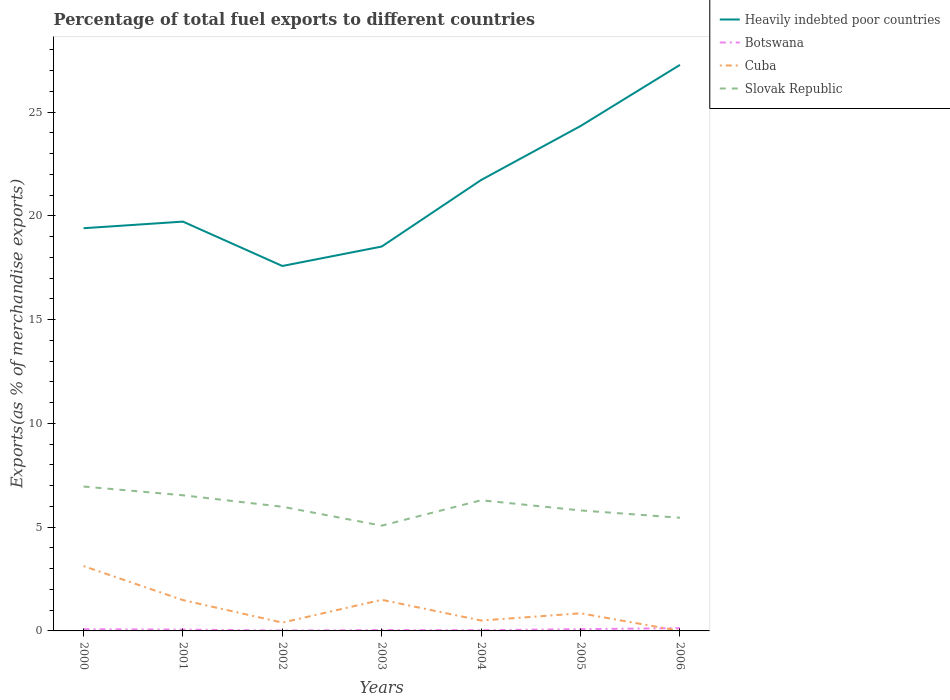Across all years, what is the maximum percentage of exports to different countries in Slovak Republic?
Your answer should be compact. 5.07. In which year was the percentage of exports to different countries in Cuba maximum?
Offer a terse response. 2006. What is the total percentage of exports to different countries in Cuba in the graph?
Give a very brief answer. -0.45. What is the difference between the highest and the second highest percentage of exports to different countries in Botswana?
Your answer should be very brief. 0.12. What is the difference between the highest and the lowest percentage of exports to different countries in Cuba?
Make the answer very short. 3. Is the percentage of exports to different countries in Slovak Republic strictly greater than the percentage of exports to different countries in Cuba over the years?
Ensure brevity in your answer.  No. How many years are there in the graph?
Keep it short and to the point. 7. What is the difference between two consecutive major ticks on the Y-axis?
Ensure brevity in your answer.  5. Does the graph contain grids?
Provide a succinct answer. No. How are the legend labels stacked?
Offer a very short reply. Vertical. What is the title of the graph?
Your answer should be compact. Percentage of total fuel exports to different countries. Does "Vietnam" appear as one of the legend labels in the graph?
Provide a short and direct response. No. What is the label or title of the X-axis?
Your response must be concise. Years. What is the label or title of the Y-axis?
Your answer should be very brief. Exports(as % of merchandise exports). What is the Exports(as % of merchandise exports) of Heavily indebted poor countries in 2000?
Make the answer very short. 19.41. What is the Exports(as % of merchandise exports) in Botswana in 2000?
Ensure brevity in your answer.  0.08. What is the Exports(as % of merchandise exports) of Cuba in 2000?
Your response must be concise. 3.13. What is the Exports(as % of merchandise exports) in Slovak Republic in 2000?
Your response must be concise. 6.96. What is the Exports(as % of merchandise exports) in Heavily indebted poor countries in 2001?
Offer a terse response. 19.73. What is the Exports(as % of merchandise exports) of Botswana in 2001?
Give a very brief answer. 0.07. What is the Exports(as % of merchandise exports) of Cuba in 2001?
Provide a short and direct response. 1.49. What is the Exports(as % of merchandise exports) of Slovak Republic in 2001?
Keep it short and to the point. 6.54. What is the Exports(as % of merchandise exports) in Heavily indebted poor countries in 2002?
Offer a terse response. 17.59. What is the Exports(as % of merchandise exports) of Botswana in 2002?
Provide a short and direct response. 0.02. What is the Exports(as % of merchandise exports) of Cuba in 2002?
Provide a succinct answer. 0.4. What is the Exports(as % of merchandise exports) of Slovak Republic in 2002?
Keep it short and to the point. 5.98. What is the Exports(as % of merchandise exports) of Heavily indebted poor countries in 2003?
Give a very brief answer. 18.52. What is the Exports(as % of merchandise exports) of Botswana in 2003?
Your response must be concise. 0.04. What is the Exports(as % of merchandise exports) in Cuba in 2003?
Your answer should be compact. 1.5. What is the Exports(as % of merchandise exports) in Slovak Republic in 2003?
Give a very brief answer. 5.07. What is the Exports(as % of merchandise exports) in Heavily indebted poor countries in 2004?
Provide a short and direct response. 21.73. What is the Exports(as % of merchandise exports) of Botswana in 2004?
Provide a succinct answer. 0.04. What is the Exports(as % of merchandise exports) in Cuba in 2004?
Offer a terse response. 0.5. What is the Exports(as % of merchandise exports) in Slovak Republic in 2004?
Provide a succinct answer. 6.3. What is the Exports(as % of merchandise exports) in Heavily indebted poor countries in 2005?
Provide a succinct answer. 24.33. What is the Exports(as % of merchandise exports) in Botswana in 2005?
Ensure brevity in your answer.  0.09. What is the Exports(as % of merchandise exports) of Cuba in 2005?
Keep it short and to the point. 0.85. What is the Exports(as % of merchandise exports) in Slovak Republic in 2005?
Provide a short and direct response. 5.81. What is the Exports(as % of merchandise exports) in Heavily indebted poor countries in 2006?
Your answer should be very brief. 27.28. What is the Exports(as % of merchandise exports) in Botswana in 2006?
Provide a short and direct response. 0.13. What is the Exports(as % of merchandise exports) in Cuba in 2006?
Offer a terse response. 0. What is the Exports(as % of merchandise exports) in Slovak Republic in 2006?
Give a very brief answer. 5.45. Across all years, what is the maximum Exports(as % of merchandise exports) in Heavily indebted poor countries?
Keep it short and to the point. 27.28. Across all years, what is the maximum Exports(as % of merchandise exports) of Botswana?
Your answer should be compact. 0.13. Across all years, what is the maximum Exports(as % of merchandise exports) of Cuba?
Keep it short and to the point. 3.13. Across all years, what is the maximum Exports(as % of merchandise exports) of Slovak Republic?
Give a very brief answer. 6.96. Across all years, what is the minimum Exports(as % of merchandise exports) in Heavily indebted poor countries?
Keep it short and to the point. 17.59. Across all years, what is the minimum Exports(as % of merchandise exports) in Botswana?
Give a very brief answer. 0.02. Across all years, what is the minimum Exports(as % of merchandise exports) of Cuba?
Your answer should be very brief. 0. Across all years, what is the minimum Exports(as % of merchandise exports) in Slovak Republic?
Offer a terse response. 5.07. What is the total Exports(as % of merchandise exports) in Heavily indebted poor countries in the graph?
Your answer should be very brief. 148.59. What is the total Exports(as % of merchandise exports) in Botswana in the graph?
Make the answer very short. 0.46. What is the total Exports(as % of merchandise exports) of Cuba in the graph?
Your answer should be compact. 7.86. What is the total Exports(as % of merchandise exports) in Slovak Republic in the graph?
Offer a very short reply. 42.11. What is the difference between the Exports(as % of merchandise exports) in Heavily indebted poor countries in 2000 and that in 2001?
Your answer should be very brief. -0.32. What is the difference between the Exports(as % of merchandise exports) in Botswana in 2000 and that in 2001?
Ensure brevity in your answer.  0.02. What is the difference between the Exports(as % of merchandise exports) in Cuba in 2000 and that in 2001?
Your answer should be compact. 1.64. What is the difference between the Exports(as % of merchandise exports) of Slovak Republic in 2000 and that in 2001?
Offer a terse response. 0.42. What is the difference between the Exports(as % of merchandise exports) of Heavily indebted poor countries in 2000 and that in 2002?
Provide a succinct answer. 1.82. What is the difference between the Exports(as % of merchandise exports) in Botswana in 2000 and that in 2002?
Make the answer very short. 0.06. What is the difference between the Exports(as % of merchandise exports) in Cuba in 2000 and that in 2002?
Offer a terse response. 2.72. What is the difference between the Exports(as % of merchandise exports) of Slovak Republic in 2000 and that in 2002?
Offer a terse response. 0.97. What is the difference between the Exports(as % of merchandise exports) in Heavily indebted poor countries in 2000 and that in 2003?
Your answer should be compact. 0.88. What is the difference between the Exports(as % of merchandise exports) in Botswana in 2000 and that in 2003?
Ensure brevity in your answer.  0.04. What is the difference between the Exports(as % of merchandise exports) of Cuba in 2000 and that in 2003?
Give a very brief answer. 1.63. What is the difference between the Exports(as % of merchandise exports) of Slovak Republic in 2000 and that in 2003?
Keep it short and to the point. 1.88. What is the difference between the Exports(as % of merchandise exports) in Heavily indebted poor countries in 2000 and that in 2004?
Keep it short and to the point. -2.32. What is the difference between the Exports(as % of merchandise exports) in Botswana in 2000 and that in 2004?
Keep it short and to the point. 0.05. What is the difference between the Exports(as % of merchandise exports) in Cuba in 2000 and that in 2004?
Make the answer very short. 2.63. What is the difference between the Exports(as % of merchandise exports) of Slovak Republic in 2000 and that in 2004?
Your answer should be compact. 0.66. What is the difference between the Exports(as % of merchandise exports) in Heavily indebted poor countries in 2000 and that in 2005?
Make the answer very short. -4.93. What is the difference between the Exports(as % of merchandise exports) in Botswana in 2000 and that in 2005?
Offer a terse response. -0. What is the difference between the Exports(as % of merchandise exports) in Cuba in 2000 and that in 2005?
Offer a very short reply. 2.28. What is the difference between the Exports(as % of merchandise exports) of Slovak Republic in 2000 and that in 2005?
Offer a very short reply. 1.15. What is the difference between the Exports(as % of merchandise exports) of Heavily indebted poor countries in 2000 and that in 2006?
Ensure brevity in your answer.  -7.87. What is the difference between the Exports(as % of merchandise exports) in Botswana in 2000 and that in 2006?
Ensure brevity in your answer.  -0.05. What is the difference between the Exports(as % of merchandise exports) of Cuba in 2000 and that in 2006?
Make the answer very short. 3.12. What is the difference between the Exports(as % of merchandise exports) of Slovak Republic in 2000 and that in 2006?
Offer a very short reply. 1.5. What is the difference between the Exports(as % of merchandise exports) of Heavily indebted poor countries in 2001 and that in 2002?
Ensure brevity in your answer.  2.14. What is the difference between the Exports(as % of merchandise exports) in Botswana in 2001 and that in 2002?
Provide a succinct answer. 0.05. What is the difference between the Exports(as % of merchandise exports) of Cuba in 2001 and that in 2002?
Give a very brief answer. 1.08. What is the difference between the Exports(as % of merchandise exports) of Slovak Republic in 2001 and that in 2002?
Your answer should be very brief. 0.55. What is the difference between the Exports(as % of merchandise exports) of Heavily indebted poor countries in 2001 and that in 2003?
Ensure brevity in your answer.  1.2. What is the difference between the Exports(as % of merchandise exports) of Botswana in 2001 and that in 2003?
Your response must be concise. 0.02. What is the difference between the Exports(as % of merchandise exports) in Cuba in 2001 and that in 2003?
Make the answer very short. -0.01. What is the difference between the Exports(as % of merchandise exports) of Slovak Republic in 2001 and that in 2003?
Keep it short and to the point. 1.46. What is the difference between the Exports(as % of merchandise exports) of Heavily indebted poor countries in 2001 and that in 2004?
Offer a very short reply. -2.01. What is the difference between the Exports(as % of merchandise exports) in Botswana in 2001 and that in 2004?
Provide a succinct answer. 0.03. What is the difference between the Exports(as % of merchandise exports) in Cuba in 2001 and that in 2004?
Offer a very short reply. 0.99. What is the difference between the Exports(as % of merchandise exports) in Slovak Republic in 2001 and that in 2004?
Provide a succinct answer. 0.24. What is the difference between the Exports(as % of merchandise exports) in Heavily indebted poor countries in 2001 and that in 2005?
Give a very brief answer. -4.61. What is the difference between the Exports(as % of merchandise exports) in Botswana in 2001 and that in 2005?
Offer a very short reply. -0.02. What is the difference between the Exports(as % of merchandise exports) of Cuba in 2001 and that in 2005?
Your response must be concise. 0.64. What is the difference between the Exports(as % of merchandise exports) of Slovak Republic in 2001 and that in 2005?
Your answer should be very brief. 0.73. What is the difference between the Exports(as % of merchandise exports) of Heavily indebted poor countries in 2001 and that in 2006?
Your response must be concise. -7.55. What is the difference between the Exports(as % of merchandise exports) of Botswana in 2001 and that in 2006?
Give a very brief answer. -0.07. What is the difference between the Exports(as % of merchandise exports) of Cuba in 2001 and that in 2006?
Your answer should be compact. 1.48. What is the difference between the Exports(as % of merchandise exports) in Slovak Republic in 2001 and that in 2006?
Offer a terse response. 1.08. What is the difference between the Exports(as % of merchandise exports) in Heavily indebted poor countries in 2002 and that in 2003?
Your answer should be very brief. -0.94. What is the difference between the Exports(as % of merchandise exports) of Botswana in 2002 and that in 2003?
Keep it short and to the point. -0.02. What is the difference between the Exports(as % of merchandise exports) of Cuba in 2002 and that in 2003?
Your response must be concise. -1.1. What is the difference between the Exports(as % of merchandise exports) in Slovak Republic in 2002 and that in 2003?
Keep it short and to the point. 0.91. What is the difference between the Exports(as % of merchandise exports) in Heavily indebted poor countries in 2002 and that in 2004?
Offer a very short reply. -4.14. What is the difference between the Exports(as % of merchandise exports) in Botswana in 2002 and that in 2004?
Provide a succinct answer. -0.02. What is the difference between the Exports(as % of merchandise exports) in Cuba in 2002 and that in 2004?
Your answer should be very brief. -0.1. What is the difference between the Exports(as % of merchandise exports) in Slovak Republic in 2002 and that in 2004?
Offer a very short reply. -0.31. What is the difference between the Exports(as % of merchandise exports) in Heavily indebted poor countries in 2002 and that in 2005?
Your response must be concise. -6.74. What is the difference between the Exports(as % of merchandise exports) of Botswana in 2002 and that in 2005?
Provide a succinct answer. -0.07. What is the difference between the Exports(as % of merchandise exports) in Cuba in 2002 and that in 2005?
Ensure brevity in your answer.  -0.45. What is the difference between the Exports(as % of merchandise exports) in Slovak Republic in 2002 and that in 2005?
Your answer should be compact. 0.18. What is the difference between the Exports(as % of merchandise exports) in Heavily indebted poor countries in 2002 and that in 2006?
Your answer should be very brief. -9.69. What is the difference between the Exports(as % of merchandise exports) of Botswana in 2002 and that in 2006?
Give a very brief answer. -0.12. What is the difference between the Exports(as % of merchandise exports) in Cuba in 2002 and that in 2006?
Ensure brevity in your answer.  0.4. What is the difference between the Exports(as % of merchandise exports) of Slovak Republic in 2002 and that in 2006?
Your response must be concise. 0.53. What is the difference between the Exports(as % of merchandise exports) of Heavily indebted poor countries in 2003 and that in 2004?
Provide a succinct answer. -3.21. What is the difference between the Exports(as % of merchandise exports) of Botswana in 2003 and that in 2004?
Provide a short and direct response. 0.01. What is the difference between the Exports(as % of merchandise exports) of Slovak Republic in 2003 and that in 2004?
Make the answer very short. -1.22. What is the difference between the Exports(as % of merchandise exports) in Heavily indebted poor countries in 2003 and that in 2005?
Keep it short and to the point. -5.81. What is the difference between the Exports(as % of merchandise exports) in Botswana in 2003 and that in 2005?
Offer a very short reply. -0.04. What is the difference between the Exports(as % of merchandise exports) in Cuba in 2003 and that in 2005?
Keep it short and to the point. 0.65. What is the difference between the Exports(as % of merchandise exports) of Slovak Republic in 2003 and that in 2005?
Keep it short and to the point. -0.73. What is the difference between the Exports(as % of merchandise exports) of Heavily indebted poor countries in 2003 and that in 2006?
Provide a short and direct response. -8.75. What is the difference between the Exports(as % of merchandise exports) of Botswana in 2003 and that in 2006?
Your answer should be compact. -0.09. What is the difference between the Exports(as % of merchandise exports) of Cuba in 2003 and that in 2006?
Offer a very short reply. 1.5. What is the difference between the Exports(as % of merchandise exports) in Slovak Republic in 2003 and that in 2006?
Your answer should be compact. -0.38. What is the difference between the Exports(as % of merchandise exports) in Heavily indebted poor countries in 2004 and that in 2005?
Make the answer very short. -2.6. What is the difference between the Exports(as % of merchandise exports) in Botswana in 2004 and that in 2005?
Your answer should be compact. -0.05. What is the difference between the Exports(as % of merchandise exports) in Cuba in 2004 and that in 2005?
Your answer should be very brief. -0.35. What is the difference between the Exports(as % of merchandise exports) of Slovak Republic in 2004 and that in 2005?
Give a very brief answer. 0.49. What is the difference between the Exports(as % of merchandise exports) of Heavily indebted poor countries in 2004 and that in 2006?
Provide a short and direct response. -5.55. What is the difference between the Exports(as % of merchandise exports) in Botswana in 2004 and that in 2006?
Provide a short and direct response. -0.1. What is the difference between the Exports(as % of merchandise exports) of Cuba in 2004 and that in 2006?
Ensure brevity in your answer.  0.5. What is the difference between the Exports(as % of merchandise exports) in Slovak Republic in 2004 and that in 2006?
Your answer should be compact. 0.84. What is the difference between the Exports(as % of merchandise exports) of Heavily indebted poor countries in 2005 and that in 2006?
Your answer should be very brief. -2.95. What is the difference between the Exports(as % of merchandise exports) of Botswana in 2005 and that in 2006?
Make the answer very short. -0.05. What is the difference between the Exports(as % of merchandise exports) in Cuba in 2005 and that in 2006?
Your answer should be compact. 0.85. What is the difference between the Exports(as % of merchandise exports) of Slovak Republic in 2005 and that in 2006?
Make the answer very short. 0.35. What is the difference between the Exports(as % of merchandise exports) of Heavily indebted poor countries in 2000 and the Exports(as % of merchandise exports) of Botswana in 2001?
Offer a terse response. 19.34. What is the difference between the Exports(as % of merchandise exports) of Heavily indebted poor countries in 2000 and the Exports(as % of merchandise exports) of Cuba in 2001?
Offer a very short reply. 17.92. What is the difference between the Exports(as % of merchandise exports) in Heavily indebted poor countries in 2000 and the Exports(as % of merchandise exports) in Slovak Republic in 2001?
Offer a very short reply. 12.87. What is the difference between the Exports(as % of merchandise exports) of Botswana in 2000 and the Exports(as % of merchandise exports) of Cuba in 2001?
Ensure brevity in your answer.  -1.4. What is the difference between the Exports(as % of merchandise exports) in Botswana in 2000 and the Exports(as % of merchandise exports) in Slovak Republic in 2001?
Give a very brief answer. -6.46. What is the difference between the Exports(as % of merchandise exports) of Cuba in 2000 and the Exports(as % of merchandise exports) of Slovak Republic in 2001?
Provide a succinct answer. -3.41. What is the difference between the Exports(as % of merchandise exports) in Heavily indebted poor countries in 2000 and the Exports(as % of merchandise exports) in Botswana in 2002?
Offer a very short reply. 19.39. What is the difference between the Exports(as % of merchandise exports) in Heavily indebted poor countries in 2000 and the Exports(as % of merchandise exports) in Cuba in 2002?
Provide a succinct answer. 19.01. What is the difference between the Exports(as % of merchandise exports) of Heavily indebted poor countries in 2000 and the Exports(as % of merchandise exports) of Slovak Republic in 2002?
Give a very brief answer. 13.42. What is the difference between the Exports(as % of merchandise exports) in Botswana in 2000 and the Exports(as % of merchandise exports) in Cuba in 2002?
Offer a terse response. -0.32. What is the difference between the Exports(as % of merchandise exports) in Botswana in 2000 and the Exports(as % of merchandise exports) in Slovak Republic in 2002?
Your answer should be compact. -5.9. What is the difference between the Exports(as % of merchandise exports) of Cuba in 2000 and the Exports(as % of merchandise exports) of Slovak Republic in 2002?
Make the answer very short. -2.86. What is the difference between the Exports(as % of merchandise exports) in Heavily indebted poor countries in 2000 and the Exports(as % of merchandise exports) in Botswana in 2003?
Offer a very short reply. 19.37. What is the difference between the Exports(as % of merchandise exports) in Heavily indebted poor countries in 2000 and the Exports(as % of merchandise exports) in Cuba in 2003?
Offer a terse response. 17.91. What is the difference between the Exports(as % of merchandise exports) of Heavily indebted poor countries in 2000 and the Exports(as % of merchandise exports) of Slovak Republic in 2003?
Offer a terse response. 14.33. What is the difference between the Exports(as % of merchandise exports) in Botswana in 2000 and the Exports(as % of merchandise exports) in Cuba in 2003?
Give a very brief answer. -1.42. What is the difference between the Exports(as % of merchandise exports) of Botswana in 2000 and the Exports(as % of merchandise exports) of Slovak Republic in 2003?
Provide a succinct answer. -4.99. What is the difference between the Exports(as % of merchandise exports) in Cuba in 2000 and the Exports(as % of merchandise exports) in Slovak Republic in 2003?
Give a very brief answer. -1.95. What is the difference between the Exports(as % of merchandise exports) of Heavily indebted poor countries in 2000 and the Exports(as % of merchandise exports) of Botswana in 2004?
Offer a very short reply. 19.37. What is the difference between the Exports(as % of merchandise exports) of Heavily indebted poor countries in 2000 and the Exports(as % of merchandise exports) of Cuba in 2004?
Your response must be concise. 18.91. What is the difference between the Exports(as % of merchandise exports) of Heavily indebted poor countries in 2000 and the Exports(as % of merchandise exports) of Slovak Republic in 2004?
Provide a succinct answer. 13.11. What is the difference between the Exports(as % of merchandise exports) in Botswana in 2000 and the Exports(as % of merchandise exports) in Cuba in 2004?
Your answer should be very brief. -0.42. What is the difference between the Exports(as % of merchandise exports) of Botswana in 2000 and the Exports(as % of merchandise exports) of Slovak Republic in 2004?
Your answer should be very brief. -6.22. What is the difference between the Exports(as % of merchandise exports) of Cuba in 2000 and the Exports(as % of merchandise exports) of Slovak Republic in 2004?
Offer a terse response. -3.17. What is the difference between the Exports(as % of merchandise exports) of Heavily indebted poor countries in 2000 and the Exports(as % of merchandise exports) of Botswana in 2005?
Offer a terse response. 19.32. What is the difference between the Exports(as % of merchandise exports) in Heavily indebted poor countries in 2000 and the Exports(as % of merchandise exports) in Cuba in 2005?
Offer a terse response. 18.56. What is the difference between the Exports(as % of merchandise exports) in Heavily indebted poor countries in 2000 and the Exports(as % of merchandise exports) in Slovak Republic in 2005?
Offer a very short reply. 13.6. What is the difference between the Exports(as % of merchandise exports) in Botswana in 2000 and the Exports(as % of merchandise exports) in Cuba in 2005?
Provide a succinct answer. -0.77. What is the difference between the Exports(as % of merchandise exports) in Botswana in 2000 and the Exports(as % of merchandise exports) in Slovak Republic in 2005?
Provide a short and direct response. -5.72. What is the difference between the Exports(as % of merchandise exports) in Cuba in 2000 and the Exports(as % of merchandise exports) in Slovak Republic in 2005?
Give a very brief answer. -2.68. What is the difference between the Exports(as % of merchandise exports) in Heavily indebted poor countries in 2000 and the Exports(as % of merchandise exports) in Botswana in 2006?
Keep it short and to the point. 19.27. What is the difference between the Exports(as % of merchandise exports) in Heavily indebted poor countries in 2000 and the Exports(as % of merchandise exports) in Cuba in 2006?
Ensure brevity in your answer.  19.41. What is the difference between the Exports(as % of merchandise exports) in Heavily indebted poor countries in 2000 and the Exports(as % of merchandise exports) in Slovak Republic in 2006?
Your answer should be compact. 13.95. What is the difference between the Exports(as % of merchandise exports) of Botswana in 2000 and the Exports(as % of merchandise exports) of Cuba in 2006?
Keep it short and to the point. 0.08. What is the difference between the Exports(as % of merchandise exports) of Botswana in 2000 and the Exports(as % of merchandise exports) of Slovak Republic in 2006?
Ensure brevity in your answer.  -5.37. What is the difference between the Exports(as % of merchandise exports) of Cuba in 2000 and the Exports(as % of merchandise exports) of Slovak Republic in 2006?
Offer a very short reply. -2.33. What is the difference between the Exports(as % of merchandise exports) in Heavily indebted poor countries in 2001 and the Exports(as % of merchandise exports) in Botswana in 2002?
Offer a terse response. 19.71. What is the difference between the Exports(as % of merchandise exports) of Heavily indebted poor countries in 2001 and the Exports(as % of merchandise exports) of Cuba in 2002?
Your response must be concise. 19.32. What is the difference between the Exports(as % of merchandise exports) in Heavily indebted poor countries in 2001 and the Exports(as % of merchandise exports) in Slovak Republic in 2002?
Provide a succinct answer. 13.74. What is the difference between the Exports(as % of merchandise exports) in Botswana in 2001 and the Exports(as % of merchandise exports) in Cuba in 2002?
Make the answer very short. -0.34. What is the difference between the Exports(as % of merchandise exports) in Botswana in 2001 and the Exports(as % of merchandise exports) in Slovak Republic in 2002?
Make the answer very short. -5.92. What is the difference between the Exports(as % of merchandise exports) in Cuba in 2001 and the Exports(as % of merchandise exports) in Slovak Republic in 2002?
Make the answer very short. -4.5. What is the difference between the Exports(as % of merchandise exports) of Heavily indebted poor countries in 2001 and the Exports(as % of merchandise exports) of Botswana in 2003?
Make the answer very short. 19.68. What is the difference between the Exports(as % of merchandise exports) of Heavily indebted poor countries in 2001 and the Exports(as % of merchandise exports) of Cuba in 2003?
Your answer should be very brief. 18.23. What is the difference between the Exports(as % of merchandise exports) in Heavily indebted poor countries in 2001 and the Exports(as % of merchandise exports) in Slovak Republic in 2003?
Ensure brevity in your answer.  14.65. What is the difference between the Exports(as % of merchandise exports) in Botswana in 2001 and the Exports(as % of merchandise exports) in Cuba in 2003?
Keep it short and to the point. -1.44. What is the difference between the Exports(as % of merchandise exports) in Botswana in 2001 and the Exports(as % of merchandise exports) in Slovak Republic in 2003?
Offer a very short reply. -5.01. What is the difference between the Exports(as % of merchandise exports) of Cuba in 2001 and the Exports(as % of merchandise exports) of Slovak Republic in 2003?
Provide a short and direct response. -3.59. What is the difference between the Exports(as % of merchandise exports) in Heavily indebted poor countries in 2001 and the Exports(as % of merchandise exports) in Botswana in 2004?
Keep it short and to the point. 19.69. What is the difference between the Exports(as % of merchandise exports) of Heavily indebted poor countries in 2001 and the Exports(as % of merchandise exports) of Cuba in 2004?
Provide a short and direct response. 19.23. What is the difference between the Exports(as % of merchandise exports) of Heavily indebted poor countries in 2001 and the Exports(as % of merchandise exports) of Slovak Republic in 2004?
Your answer should be very brief. 13.43. What is the difference between the Exports(as % of merchandise exports) of Botswana in 2001 and the Exports(as % of merchandise exports) of Cuba in 2004?
Provide a short and direct response. -0.44. What is the difference between the Exports(as % of merchandise exports) in Botswana in 2001 and the Exports(as % of merchandise exports) in Slovak Republic in 2004?
Your response must be concise. -6.23. What is the difference between the Exports(as % of merchandise exports) in Cuba in 2001 and the Exports(as % of merchandise exports) in Slovak Republic in 2004?
Give a very brief answer. -4.81. What is the difference between the Exports(as % of merchandise exports) of Heavily indebted poor countries in 2001 and the Exports(as % of merchandise exports) of Botswana in 2005?
Offer a very short reply. 19.64. What is the difference between the Exports(as % of merchandise exports) in Heavily indebted poor countries in 2001 and the Exports(as % of merchandise exports) in Cuba in 2005?
Your answer should be very brief. 18.88. What is the difference between the Exports(as % of merchandise exports) in Heavily indebted poor countries in 2001 and the Exports(as % of merchandise exports) in Slovak Republic in 2005?
Give a very brief answer. 13.92. What is the difference between the Exports(as % of merchandise exports) of Botswana in 2001 and the Exports(as % of merchandise exports) of Cuba in 2005?
Make the answer very short. -0.78. What is the difference between the Exports(as % of merchandise exports) in Botswana in 2001 and the Exports(as % of merchandise exports) in Slovak Republic in 2005?
Provide a succinct answer. -5.74. What is the difference between the Exports(as % of merchandise exports) in Cuba in 2001 and the Exports(as % of merchandise exports) in Slovak Republic in 2005?
Offer a very short reply. -4.32. What is the difference between the Exports(as % of merchandise exports) in Heavily indebted poor countries in 2001 and the Exports(as % of merchandise exports) in Botswana in 2006?
Your answer should be very brief. 19.59. What is the difference between the Exports(as % of merchandise exports) in Heavily indebted poor countries in 2001 and the Exports(as % of merchandise exports) in Cuba in 2006?
Make the answer very short. 19.72. What is the difference between the Exports(as % of merchandise exports) in Heavily indebted poor countries in 2001 and the Exports(as % of merchandise exports) in Slovak Republic in 2006?
Ensure brevity in your answer.  14.27. What is the difference between the Exports(as % of merchandise exports) of Botswana in 2001 and the Exports(as % of merchandise exports) of Cuba in 2006?
Give a very brief answer. 0.06. What is the difference between the Exports(as % of merchandise exports) in Botswana in 2001 and the Exports(as % of merchandise exports) in Slovak Republic in 2006?
Offer a very short reply. -5.39. What is the difference between the Exports(as % of merchandise exports) in Cuba in 2001 and the Exports(as % of merchandise exports) in Slovak Republic in 2006?
Offer a very short reply. -3.97. What is the difference between the Exports(as % of merchandise exports) of Heavily indebted poor countries in 2002 and the Exports(as % of merchandise exports) of Botswana in 2003?
Your response must be concise. 17.55. What is the difference between the Exports(as % of merchandise exports) of Heavily indebted poor countries in 2002 and the Exports(as % of merchandise exports) of Cuba in 2003?
Ensure brevity in your answer.  16.09. What is the difference between the Exports(as % of merchandise exports) in Heavily indebted poor countries in 2002 and the Exports(as % of merchandise exports) in Slovak Republic in 2003?
Provide a short and direct response. 12.51. What is the difference between the Exports(as % of merchandise exports) of Botswana in 2002 and the Exports(as % of merchandise exports) of Cuba in 2003?
Your answer should be compact. -1.48. What is the difference between the Exports(as % of merchandise exports) of Botswana in 2002 and the Exports(as % of merchandise exports) of Slovak Republic in 2003?
Ensure brevity in your answer.  -5.06. What is the difference between the Exports(as % of merchandise exports) of Cuba in 2002 and the Exports(as % of merchandise exports) of Slovak Republic in 2003?
Make the answer very short. -4.67. What is the difference between the Exports(as % of merchandise exports) of Heavily indebted poor countries in 2002 and the Exports(as % of merchandise exports) of Botswana in 2004?
Your response must be concise. 17.55. What is the difference between the Exports(as % of merchandise exports) in Heavily indebted poor countries in 2002 and the Exports(as % of merchandise exports) in Cuba in 2004?
Your answer should be very brief. 17.09. What is the difference between the Exports(as % of merchandise exports) of Heavily indebted poor countries in 2002 and the Exports(as % of merchandise exports) of Slovak Republic in 2004?
Give a very brief answer. 11.29. What is the difference between the Exports(as % of merchandise exports) of Botswana in 2002 and the Exports(as % of merchandise exports) of Cuba in 2004?
Ensure brevity in your answer.  -0.48. What is the difference between the Exports(as % of merchandise exports) in Botswana in 2002 and the Exports(as % of merchandise exports) in Slovak Republic in 2004?
Your response must be concise. -6.28. What is the difference between the Exports(as % of merchandise exports) in Cuba in 2002 and the Exports(as % of merchandise exports) in Slovak Republic in 2004?
Provide a short and direct response. -5.9. What is the difference between the Exports(as % of merchandise exports) in Heavily indebted poor countries in 2002 and the Exports(as % of merchandise exports) in Botswana in 2005?
Your response must be concise. 17.5. What is the difference between the Exports(as % of merchandise exports) of Heavily indebted poor countries in 2002 and the Exports(as % of merchandise exports) of Cuba in 2005?
Provide a short and direct response. 16.74. What is the difference between the Exports(as % of merchandise exports) in Heavily indebted poor countries in 2002 and the Exports(as % of merchandise exports) in Slovak Republic in 2005?
Offer a very short reply. 11.78. What is the difference between the Exports(as % of merchandise exports) in Botswana in 2002 and the Exports(as % of merchandise exports) in Cuba in 2005?
Provide a succinct answer. -0.83. What is the difference between the Exports(as % of merchandise exports) of Botswana in 2002 and the Exports(as % of merchandise exports) of Slovak Republic in 2005?
Ensure brevity in your answer.  -5.79. What is the difference between the Exports(as % of merchandise exports) of Cuba in 2002 and the Exports(as % of merchandise exports) of Slovak Republic in 2005?
Ensure brevity in your answer.  -5.4. What is the difference between the Exports(as % of merchandise exports) of Heavily indebted poor countries in 2002 and the Exports(as % of merchandise exports) of Botswana in 2006?
Offer a terse response. 17.45. What is the difference between the Exports(as % of merchandise exports) in Heavily indebted poor countries in 2002 and the Exports(as % of merchandise exports) in Cuba in 2006?
Offer a terse response. 17.59. What is the difference between the Exports(as % of merchandise exports) of Heavily indebted poor countries in 2002 and the Exports(as % of merchandise exports) of Slovak Republic in 2006?
Keep it short and to the point. 12.13. What is the difference between the Exports(as % of merchandise exports) in Botswana in 2002 and the Exports(as % of merchandise exports) in Cuba in 2006?
Give a very brief answer. 0.02. What is the difference between the Exports(as % of merchandise exports) in Botswana in 2002 and the Exports(as % of merchandise exports) in Slovak Republic in 2006?
Ensure brevity in your answer.  -5.44. What is the difference between the Exports(as % of merchandise exports) in Cuba in 2002 and the Exports(as % of merchandise exports) in Slovak Republic in 2006?
Make the answer very short. -5.05. What is the difference between the Exports(as % of merchandise exports) of Heavily indebted poor countries in 2003 and the Exports(as % of merchandise exports) of Botswana in 2004?
Your answer should be compact. 18.49. What is the difference between the Exports(as % of merchandise exports) in Heavily indebted poor countries in 2003 and the Exports(as % of merchandise exports) in Cuba in 2004?
Offer a very short reply. 18.02. What is the difference between the Exports(as % of merchandise exports) in Heavily indebted poor countries in 2003 and the Exports(as % of merchandise exports) in Slovak Republic in 2004?
Offer a very short reply. 12.23. What is the difference between the Exports(as % of merchandise exports) of Botswana in 2003 and the Exports(as % of merchandise exports) of Cuba in 2004?
Your response must be concise. -0.46. What is the difference between the Exports(as % of merchandise exports) of Botswana in 2003 and the Exports(as % of merchandise exports) of Slovak Republic in 2004?
Offer a terse response. -6.26. What is the difference between the Exports(as % of merchandise exports) of Cuba in 2003 and the Exports(as % of merchandise exports) of Slovak Republic in 2004?
Ensure brevity in your answer.  -4.8. What is the difference between the Exports(as % of merchandise exports) in Heavily indebted poor countries in 2003 and the Exports(as % of merchandise exports) in Botswana in 2005?
Your response must be concise. 18.44. What is the difference between the Exports(as % of merchandise exports) in Heavily indebted poor countries in 2003 and the Exports(as % of merchandise exports) in Cuba in 2005?
Offer a terse response. 17.68. What is the difference between the Exports(as % of merchandise exports) of Heavily indebted poor countries in 2003 and the Exports(as % of merchandise exports) of Slovak Republic in 2005?
Offer a terse response. 12.72. What is the difference between the Exports(as % of merchandise exports) of Botswana in 2003 and the Exports(as % of merchandise exports) of Cuba in 2005?
Offer a very short reply. -0.81. What is the difference between the Exports(as % of merchandise exports) in Botswana in 2003 and the Exports(as % of merchandise exports) in Slovak Republic in 2005?
Give a very brief answer. -5.77. What is the difference between the Exports(as % of merchandise exports) in Cuba in 2003 and the Exports(as % of merchandise exports) in Slovak Republic in 2005?
Offer a very short reply. -4.31. What is the difference between the Exports(as % of merchandise exports) in Heavily indebted poor countries in 2003 and the Exports(as % of merchandise exports) in Botswana in 2006?
Offer a very short reply. 18.39. What is the difference between the Exports(as % of merchandise exports) in Heavily indebted poor countries in 2003 and the Exports(as % of merchandise exports) in Cuba in 2006?
Your answer should be compact. 18.52. What is the difference between the Exports(as % of merchandise exports) of Heavily indebted poor countries in 2003 and the Exports(as % of merchandise exports) of Slovak Republic in 2006?
Make the answer very short. 13.07. What is the difference between the Exports(as % of merchandise exports) of Botswana in 2003 and the Exports(as % of merchandise exports) of Cuba in 2006?
Your answer should be very brief. 0.04. What is the difference between the Exports(as % of merchandise exports) of Botswana in 2003 and the Exports(as % of merchandise exports) of Slovak Republic in 2006?
Offer a terse response. -5.41. What is the difference between the Exports(as % of merchandise exports) of Cuba in 2003 and the Exports(as % of merchandise exports) of Slovak Republic in 2006?
Your answer should be very brief. -3.95. What is the difference between the Exports(as % of merchandise exports) of Heavily indebted poor countries in 2004 and the Exports(as % of merchandise exports) of Botswana in 2005?
Give a very brief answer. 21.65. What is the difference between the Exports(as % of merchandise exports) in Heavily indebted poor countries in 2004 and the Exports(as % of merchandise exports) in Cuba in 2005?
Ensure brevity in your answer.  20.88. What is the difference between the Exports(as % of merchandise exports) of Heavily indebted poor countries in 2004 and the Exports(as % of merchandise exports) of Slovak Republic in 2005?
Keep it short and to the point. 15.92. What is the difference between the Exports(as % of merchandise exports) in Botswana in 2004 and the Exports(as % of merchandise exports) in Cuba in 2005?
Provide a succinct answer. -0.81. What is the difference between the Exports(as % of merchandise exports) in Botswana in 2004 and the Exports(as % of merchandise exports) in Slovak Republic in 2005?
Give a very brief answer. -5.77. What is the difference between the Exports(as % of merchandise exports) of Cuba in 2004 and the Exports(as % of merchandise exports) of Slovak Republic in 2005?
Make the answer very short. -5.31. What is the difference between the Exports(as % of merchandise exports) in Heavily indebted poor countries in 2004 and the Exports(as % of merchandise exports) in Botswana in 2006?
Make the answer very short. 21.6. What is the difference between the Exports(as % of merchandise exports) in Heavily indebted poor countries in 2004 and the Exports(as % of merchandise exports) in Cuba in 2006?
Provide a short and direct response. 21.73. What is the difference between the Exports(as % of merchandise exports) in Heavily indebted poor countries in 2004 and the Exports(as % of merchandise exports) in Slovak Republic in 2006?
Offer a very short reply. 16.28. What is the difference between the Exports(as % of merchandise exports) in Botswana in 2004 and the Exports(as % of merchandise exports) in Cuba in 2006?
Provide a succinct answer. 0.03. What is the difference between the Exports(as % of merchandise exports) in Botswana in 2004 and the Exports(as % of merchandise exports) in Slovak Republic in 2006?
Your answer should be very brief. -5.42. What is the difference between the Exports(as % of merchandise exports) in Cuba in 2004 and the Exports(as % of merchandise exports) in Slovak Republic in 2006?
Offer a terse response. -4.95. What is the difference between the Exports(as % of merchandise exports) in Heavily indebted poor countries in 2005 and the Exports(as % of merchandise exports) in Botswana in 2006?
Your answer should be very brief. 24.2. What is the difference between the Exports(as % of merchandise exports) of Heavily indebted poor countries in 2005 and the Exports(as % of merchandise exports) of Cuba in 2006?
Your response must be concise. 24.33. What is the difference between the Exports(as % of merchandise exports) in Heavily indebted poor countries in 2005 and the Exports(as % of merchandise exports) in Slovak Republic in 2006?
Provide a succinct answer. 18.88. What is the difference between the Exports(as % of merchandise exports) in Botswana in 2005 and the Exports(as % of merchandise exports) in Cuba in 2006?
Provide a short and direct response. 0.08. What is the difference between the Exports(as % of merchandise exports) of Botswana in 2005 and the Exports(as % of merchandise exports) of Slovak Republic in 2006?
Give a very brief answer. -5.37. What is the difference between the Exports(as % of merchandise exports) in Cuba in 2005 and the Exports(as % of merchandise exports) in Slovak Republic in 2006?
Provide a short and direct response. -4.6. What is the average Exports(as % of merchandise exports) in Heavily indebted poor countries per year?
Keep it short and to the point. 21.23. What is the average Exports(as % of merchandise exports) in Botswana per year?
Your answer should be very brief. 0.07. What is the average Exports(as % of merchandise exports) in Cuba per year?
Offer a very short reply. 1.12. What is the average Exports(as % of merchandise exports) of Slovak Republic per year?
Offer a terse response. 6.02. In the year 2000, what is the difference between the Exports(as % of merchandise exports) of Heavily indebted poor countries and Exports(as % of merchandise exports) of Botswana?
Offer a very short reply. 19.32. In the year 2000, what is the difference between the Exports(as % of merchandise exports) in Heavily indebted poor countries and Exports(as % of merchandise exports) in Cuba?
Provide a succinct answer. 16.28. In the year 2000, what is the difference between the Exports(as % of merchandise exports) in Heavily indebted poor countries and Exports(as % of merchandise exports) in Slovak Republic?
Offer a very short reply. 12.45. In the year 2000, what is the difference between the Exports(as % of merchandise exports) in Botswana and Exports(as % of merchandise exports) in Cuba?
Offer a very short reply. -3.04. In the year 2000, what is the difference between the Exports(as % of merchandise exports) in Botswana and Exports(as % of merchandise exports) in Slovak Republic?
Offer a terse response. -6.88. In the year 2000, what is the difference between the Exports(as % of merchandise exports) of Cuba and Exports(as % of merchandise exports) of Slovak Republic?
Make the answer very short. -3.83. In the year 2001, what is the difference between the Exports(as % of merchandise exports) in Heavily indebted poor countries and Exports(as % of merchandise exports) in Botswana?
Your answer should be compact. 19.66. In the year 2001, what is the difference between the Exports(as % of merchandise exports) of Heavily indebted poor countries and Exports(as % of merchandise exports) of Cuba?
Make the answer very short. 18.24. In the year 2001, what is the difference between the Exports(as % of merchandise exports) of Heavily indebted poor countries and Exports(as % of merchandise exports) of Slovak Republic?
Keep it short and to the point. 13.19. In the year 2001, what is the difference between the Exports(as % of merchandise exports) in Botswana and Exports(as % of merchandise exports) in Cuba?
Provide a short and direct response. -1.42. In the year 2001, what is the difference between the Exports(as % of merchandise exports) in Botswana and Exports(as % of merchandise exports) in Slovak Republic?
Ensure brevity in your answer.  -6.47. In the year 2001, what is the difference between the Exports(as % of merchandise exports) of Cuba and Exports(as % of merchandise exports) of Slovak Republic?
Your answer should be compact. -5.05. In the year 2002, what is the difference between the Exports(as % of merchandise exports) in Heavily indebted poor countries and Exports(as % of merchandise exports) in Botswana?
Provide a succinct answer. 17.57. In the year 2002, what is the difference between the Exports(as % of merchandise exports) in Heavily indebted poor countries and Exports(as % of merchandise exports) in Cuba?
Your answer should be very brief. 17.19. In the year 2002, what is the difference between the Exports(as % of merchandise exports) in Heavily indebted poor countries and Exports(as % of merchandise exports) in Slovak Republic?
Your answer should be very brief. 11.6. In the year 2002, what is the difference between the Exports(as % of merchandise exports) in Botswana and Exports(as % of merchandise exports) in Cuba?
Provide a succinct answer. -0.38. In the year 2002, what is the difference between the Exports(as % of merchandise exports) of Botswana and Exports(as % of merchandise exports) of Slovak Republic?
Offer a terse response. -5.97. In the year 2002, what is the difference between the Exports(as % of merchandise exports) in Cuba and Exports(as % of merchandise exports) in Slovak Republic?
Provide a short and direct response. -5.58. In the year 2003, what is the difference between the Exports(as % of merchandise exports) of Heavily indebted poor countries and Exports(as % of merchandise exports) of Botswana?
Make the answer very short. 18.48. In the year 2003, what is the difference between the Exports(as % of merchandise exports) of Heavily indebted poor countries and Exports(as % of merchandise exports) of Cuba?
Offer a terse response. 17.02. In the year 2003, what is the difference between the Exports(as % of merchandise exports) of Heavily indebted poor countries and Exports(as % of merchandise exports) of Slovak Republic?
Your response must be concise. 13.45. In the year 2003, what is the difference between the Exports(as % of merchandise exports) of Botswana and Exports(as % of merchandise exports) of Cuba?
Your answer should be compact. -1.46. In the year 2003, what is the difference between the Exports(as % of merchandise exports) in Botswana and Exports(as % of merchandise exports) in Slovak Republic?
Give a very brief answer. -5.03. In the year 2003, what is the difference between the Exports(as % of merchandise exports) of Cuba and Exports(as % of merchandise exports) of Slovak Republic?
Offer a terse response. -3.57. In the year 2004, what is the difference between the Exports(as % of merchandise exports) of Heavily indebted poor countries and Exports(as % of merchandise exports) of Botswana?
Give a very brief answer. 21.7. In the year 2004, what is the difference between the Exports(as % of merchandise exports) in Heavily indebted poor countries and Exports(as % of merchandise exports) in Cuba?
Offer a terse response. 21.23. In the year 2004, what is the difference between the Exports(as % of merchandise exports) in Heavily indebted poor countries and Exports(as % of merchandise exports) in Slovak Republic?
Provide a short and direct response. 15.43. In the year 2004, what is the difference between the Exports(as % of merchandise exports) in Botswana and Exports(as % of merchandise exports) in Cuba?
Give a very brief answer. -0.47. In the year 2004, what is the difference between the Exports(as % of merchandise exports) of Botswana and Exports(as % of merchandise exports) of Slovak Republic?
Your answer should be compact. -6.26. In the year 2004, what is the difference between the Exports(as % of merchandise exports) in Cuba and Exports(as % of merchandise exports) in Slovak Republic?
Keep it short and to the point. -5.8. In the year 2005, what is the difference between the Exports(as % of merchandise exports) of Heavily indebted poor countries and Exports(as % of merchandise exports) of Botswana?
Ensure brevity in your answer.  24.25. In the year 2005, what is the difference between the Exports(as % of merchandise exports) in Heavily indebted poor countries and Exports(as % of merchandise exports) in Cuba?
Your answer should be compact. 23.48. In the year 2005, what is the difference between the Exports(as % of merchandise exports) in Heavily indebted poor countries and Exports(as % of merchandise exports) in Slovak Republic?
Offer a very short reply. 18.53. In the year 2005, what is the difference between the Exports(as % of merchandise exports) of Botswana and Exports(as % of merchandise exports) of Cuba?
Offer a terse response. -0.76. In the year 2005, what is the difference between the Exports(as % of merchandise exports) in Botswana and Exports(as % of merchandise exports) in Slovak Republic?
Your answer should be compact. -5.72. In the year 2005, what is the difference between the Exports(as % of merchandise exports) in Cuba and Exports(as % of merchandise exports) in Slovak Republic?
Ensure brevity in your answer.  -4.96. In the year 2006, what is the difference between the Exports(as % of merchandise exports) of Heavily indebted poor countries and Exports(as % of merchandise exports) of Botswana?
Your response must be concise. 27.15. In the year 2006, what is the difference between the Exports(as % of merchandise exports) in Heavily indebted poor countries and Exports(as % of merchandise exports) in Cuba?
Give a very brief answer. 27.28. In the year 2006, what is the difference between the Exports(as % of merchandise exports) in Heavily indebted poor countries and Exports(as % of merchandise exports) in Slovak Republic?
Your response must be concise. 21.83. In the year 2006, what is the difference between the Exports(as % of merchandise exports) of Botswana and Exports(as % of merchandise exports) of Cuba?
Provide a succinct answer. 0.13. In the year 2006, what is the difference between the Exports(as % of merchandise exports) of Botswana and Exports(as % of merchandise exports) of Slovak Republic?
Your answer should be very brief. -5.32. In the year 2006, what is the difference between the Exports(as % of merchandise exports) of Cuba and Exports(as % of merchandise exports) of Slovak Republic?
Provide a short and direct response. -5.45. What is the ratio of the Exports(as % of merchandise exports) of Heavily indebted poor countries in 2000 to that in 2001?
Your response must be concise. 0.98. What is the ratio of the Exports(as % of merchandise exports) of Botswana in 2000 to that in 2001?
Provide a succinct answer. 1.25. What is the ratio of the Exports(as % of merchandise exports) in Cuba in 2000 to that in 2001?
Offer a terse response. 2.1. What is the ratio of the Exports(as % of merchandise exports) of Slovak Republic in 2000 to that in 2001?
Your response must be concise. 1.06. What is the ratio of the Exports(as % of merchandise exports) in Heavily indebted poor countries in 2000 to that in 2002?
Give a very brief answer. 1.1. What is the ratio of the Exports(as % of merchandise exports) in Botswana in 2000 to that in 2002?
Your response must be concise. 4.69. What is the ratio of the Exports(as % of merchandise exports) in Cuba in 2000 to that in 2002?
Keep it short and to the point. 7.78. What is the ratio of the Exports(as % of merchandise exports) in Slovak Republic in 2000 to that in 2002?
Your response must be concise. 1.16. What is the ratio of the Exports(as % of merchandise exports) in Heavily indebted poor countries in 2000 to that in 2003?
Provide a short and direct response. 1.05. What is the ratio of the Exports(as % of merchandise exports) of Botswana in 2000 to that in 2003?
Provide a short and direct response. 1.99. What is the ratio of the Exports(as % of merchandise exports) of Cuba in 2000 to that in 2003?
Provide a succinct answer. 2.08. What is the ratio of the Exports(as % of merchandise exports) in Slovak Republic in 2000 to that in 2003?
Offer a terse response. 1.37. What is the ratio of the Exports(as % of merchandise exports) in Heavily indebted poor countries in 2000 to that in 2004?
Offer a very short reply. 0.89. What is the ratio of the Exports(as % of merchandise exports) in Botswana in 2000 to that in 2004?
Your answer should be compact. 2.32. What is the ratio of the Exports(as % of merchandise exports) of Cuba in 2000 to that in 2004?
Provide a succinct answer. 6.25. What is the ratio of the Exports(as % of merchandise exports) of Slovak Republic in 2000 to that in 2004?
Keep it short and to the point. 1.1. What is the ratio of the Exports(as % of merchandise exports) of Heavily indebted poor countries in 2000 to that in 2005?
Provide a succinct answer. 0.8. What is the ratio of the Exports(as % of merchandise exports) of Botswana in 2000 to that in 2005?
Ensure brevity in your answer.  0.96. What is the ratio of the Exports(as % of merchandise exports) of Cuba in 2000 to that in 2005?
Give a very brief answer. 3.68. What is the ratio of the Exports(as % of merchandise exports) in Slovak Republic in 2000 to that in 2005?
Offer a terse response. 1.2. What is the ratio of the Exports(as % of merchandise exports) in Heavily indebted poor countries in 2000 to that in 2006?
Give a very brief answer. 0.71. What is the ratio of the Exports(as % of merchandise exports) in Botswana in 2000 to that in 2006?
Give a very brief answer. 0.61. What is the ratio of the Exports(as % of merchandise exports) of Cuba in 2000 to that in 2006?
Offer a terse response. 2046.61. What is the ratio of the Exports(as % of merchandise exports) in Slovak Republic in 2000 to that in 2006?
Keep it short and to the point. 1.28. What is the ratio of the Exports(as % of merchandise exports) of Heavily indebted poor countries in 2001 to that in 2002?
Keep it short and to the point. 1.12. What is the ratio of the Exports(as % of merchandise exports) in Botswana in 2001 to that in 2002?
Offer a very short reply. 3.74. What is the ratio of the Exports(as % of merchandise exports) of Cuba in 2001 to that in 2002?
Your answer should be very brief. 3.7. What is the ratio of the Exports(as % of merchandise exports) in Slovak Republic in 2001 to that in 2002?
Your answer should be compact. 1.09. What is the ratio of the Exports(as % of merchandise exports) in Heavily indebted poor countries in 2001 to that in 2003?
Your answer should be very brief. 1.06. What is the ratio of the Exports(as % of merchandise exports) in Botswana in 2001 to that in 2003?
Your response must be concise. 1.58. What is the ratio of the Exports(as % of merchandise exports) of Cuba in 2001 to that in 2003?
Provide a succinct answer. 0.99. What is the ratio of the Exports(as % of merchandise exports) of Slovak Republic in 2001 to that in 2003?
Your answer should be very brief. 1.29. What is the ratio of the Exports(as % of merchandise exports) of Heavily indebted poor countries in 2001 to that in 2004?
Give a very brief answer. 0.91. What is the ratio of the Exports(as % of merchandise exports) in Botswana in 2001 to that in 2004?
Provide a short and direct response. 1.85. What is the ratio of the Exports(as % of merchandise exports) of Cuba in 2001 to that in 2004?
Keep it short and to the point. 2.97. What is the ratio of the Exports(as % of merchandise exports) in Slovak Republic in 2001 to that in 2004?
Your answer should be very brief. 1.04. What is the ratio of the Exports(as % of merchandise exports) of Heavily indebted poor countries in 2001 to that in 2005?
Provide a succinct answer. 0.81. What is the ratio of the Exports(as % of merchandise exports) in Botswana in 2001 to that in 2005?
Ensure brevity in your answer.  0.76. What is the ratio of the Exports(as % of merchandise exports) of Cuba in 2001 to that in 2005?
Keep it short and to the point. 1.75. What is the ratio of the Exports(as % of merchandise exports) of Slovak Republic in 2001 to that in 2005?
Keep it short and to the point. 1.13. What is the ratio of the Exports(as % of merchandise exports) in Heavily indebted poor countries in 2001 to that in 2006?
Make the answer very short. 0.72. What is the ratio of the Exports(as % of merchandise exports) in Botswana in 2001 to that in 2006?
Make the answer very short. 0.49. What is the ratio of the Exports(as % of merchandise exports) in Cuba in 2001 to that in 2006?
Your response must be concise. 972.99. What is the ratio of the Exports(as % of merchandise exports) in Slovak Republic in 2001 to that in 2006?
Keep it short and to the point. 1.2. What is the ratio of the Exports(as % of merchandise exports) of Heavily indebted poor countries in 2002 to that in 2003?
Your response must be concise. 0.95. What is the ratio of the Exports(as % of merchandise exports) of Botswana in 2002 to that in 2003?
Your response must be concise. 0.42. What is the ratio of the Exports(as % of merchandise exports) in Cuba in 2002 to that in 2003?
Keep it short and to the point. 0.27. What is the ratio of the Exports(as % of merchandise exports) of Slovak Republic in 2002 to that in 2003?
Offer a very short reply. 1.18. What is the ratio of the Exports(as % of merchandise exports) of Heavily indebted poor countries in 2002 to that in 2004?
Your answer should be very brief. 0.81. What is the ratio of the Exports(as % of merchandise exports) in Botswana in 2002 to that in 2004?
Your response must be concise. 0.49. What is the ratio of the Exports(as % of merchandise exports) in Cuba in 2002 to that in 2004?
Provide a succinct answer. 0.8. What is the ratio of the Exports(as % of merchandise exports) in Slovak Republic in 2002 to that in 2004?
Provide a succinct answer. 0.95. What is the ratio of the Exports(as % of merchandise exports) in Heavily indebted poor countries in 2002 to that in 2005?
Offer a terse response. 0.72. What is the ratio of the Exports(as % of merchandise exports) of Botswana in 2002 to that in 2005?
Give a very brief answer. 0.2. What is the ratio of the Exports(as % of merchandise exports) in Cuba in 2002 to that in 2005?
Ensure brevity in your answer.  0.47. What is the ratio of the Exports(as % of merchandise exports) in Slovak Republic in 2002 to that in 2005?
Give a very brief answer. 1.03. What is the ratio of the Exports(as % of merchandise exports) in Heavily indebted poor countries in 2002 to that in 2006?
Keep it short and to the point. 0.64. What is the ratio of the Exports(as % of merchandise exports) in Botswana in 2002 to that in 2006?
Make the answer very short. 0.13. What is the ratio of the Exports(as % of merchandise exports) of Cuba in 2002 to that in 2006?
Your answer should be compact. 263.05. What is the ratio of the Exports(as % of merchandise exports) in Slovak Republic in 2002 to that in 2006?
Your answer should be very brief. 1.1. What is the ratio of the Exports(as % of merchandise exports) in Heavily indebted poor countries in 2003 to that in 2004?
Give a very brief answer. 0.85. What is the ratio of the Exports(as % of merchandise exports) in Botswana in 2003 to that in 2004?
Your response must be concise. 1.17. What is the ratio of the Exports(as % of merchandise exports) of Cuba in 2003 to that in 2004?
Make the answer very short. 3. What is the ratio of the Exports(as % of merchandise exports) of Slovak Republic in 2003 to that in 2004?
Your response must be concise. 0.81. What is the ratio of the Exports(as % of merchandise exports) in Heavily indebted poor countries in 2003 to that in 2005?
Ensure brevity in your answer.  0.76. What is the ratio of the Exports(as % of merchandise exports) in Botswana in 2003 to that in 2005?
Your answer should be very brief. 0.48. What is the ratio of the Exports(as % of merchandise exports) of Cuba in 2003 to that in 2005?
Provide a short and direct response. 1.77. What is the ratio of the Exports(as % of merchandise exports) of Slovak Republic in 2003 to that in 2005?
Your answer should be compact. 0.87. What is the ratio of the Exports(as % of merchandise exports) of Heavily indebted poor countries in 2003 to that in 2006?
Keep it short and to the point. 0.68. What is the ratio of the Exports(as % of merchandise exports) in Botswana in 2003 to that in 2006?
Offer a very short reply. 0.31. What is the ratio of the Exports(as % of merchandise exports) of Cuba in 2003 to that in 2006?
Your answer should be compact. 982.27. What is the ratio of the Exports(as % of merchandise exports) in Slovak Republic in 2003 to that in 2006?
Provide a succinct answer. 0.93. What is the ratio of the Exports(as % of merchandise exports) of Heavily indebted poor countries in 2004 to that in 2005?
Offer a terse response. 0.89. What is the ratio of the Exports(as % of merchandise exports) of Botswana in 2004 to that in 2005?
Ensure brevity in your answer.  0.41. What is the ratio of the Exports(as % of merchandise exports) of Cuba in 2004 to that in 2005?
Give a very brief answer. 0.59. What is the ratio of the Exports(as % of merchandise exports) of Slovak Republic in 2004 to that in 2005?
Ensure brevity in your answer.  1.08. What is the ratio of the Exports(as % of merchandise exports) of Heavily indebted poor countries in 2004 to that in 2006?
Make the answer very short. 0.8. What is the ratio of the Exports(as % of merchandise exports) in Botswana in 2004 to that in 2006?
Offer a terse response. 0.26. What is the ratio of the Exports(as % of merchandise exports) of Cuba in 2004 to that in 2006?
Ensure brevity in your answer.  327.57. What is the ratio of the Exports(as % of merchandise exports) of Slovak Republic in 2004 to that in 2006?
Your answer should be very brief. 1.15. What is the ratio of the Exports(as % of merchandise exports) in Heavily indebted poor countries in 2005 to that in 2006?
Provide a short and direct response. 0.89. What is the ratio of the Exports(as % of merchandise exports) of Botswana in 2005 to that in 2006?
Provide a short and direct response. 0.64. What is the ratio of the Exports(as % of merchandise exports) in Cuba in 2005 to that in 2006?
Offer a terse response. 556.27. What is the ratio of the Exports(as % of merchandise exports) in Slovak Republic in 2005 to that in 2006?
Offer a terse response. 1.06. What is the difference between the highest and the second highest Exports(as % of merchandise exports) of Heavily indebted poor countries?
Provide a short and direct response. 2.95. What is the difference between the highest and the second highest Exports(as % of merchandise exports) in Botswana?
Offer a very short reply. 0.05. What is the difference between the highest and the second highest Exports(as % of merchandise exports) of Cuba?
Your answer should be very brief. 1.63. What is the difference between the highest and the second highest Exports(as % of merchandise exports) in Slovak Republic?
Ensure brevity in your answer.  0.42. What is the difference between the highest and the lowest Exports(as % of merchandise exports) in Heavily indebted poor countries?
Make the answer very short. 9.69. What is the difference between the highest and the lowest Exports(as % of merchandise exports) of Botswana?
Provide a succinct answer. 0.12. What is the difference between the highest and the lowest Exports(as % of merchandise exports) in Cuba?
Your answer should be compact. 3.12. What is the difference between the highest and the lowest Exports(as % of merchandise exports) of Slovak Republic?
Give a very brief answer. 1.88. 